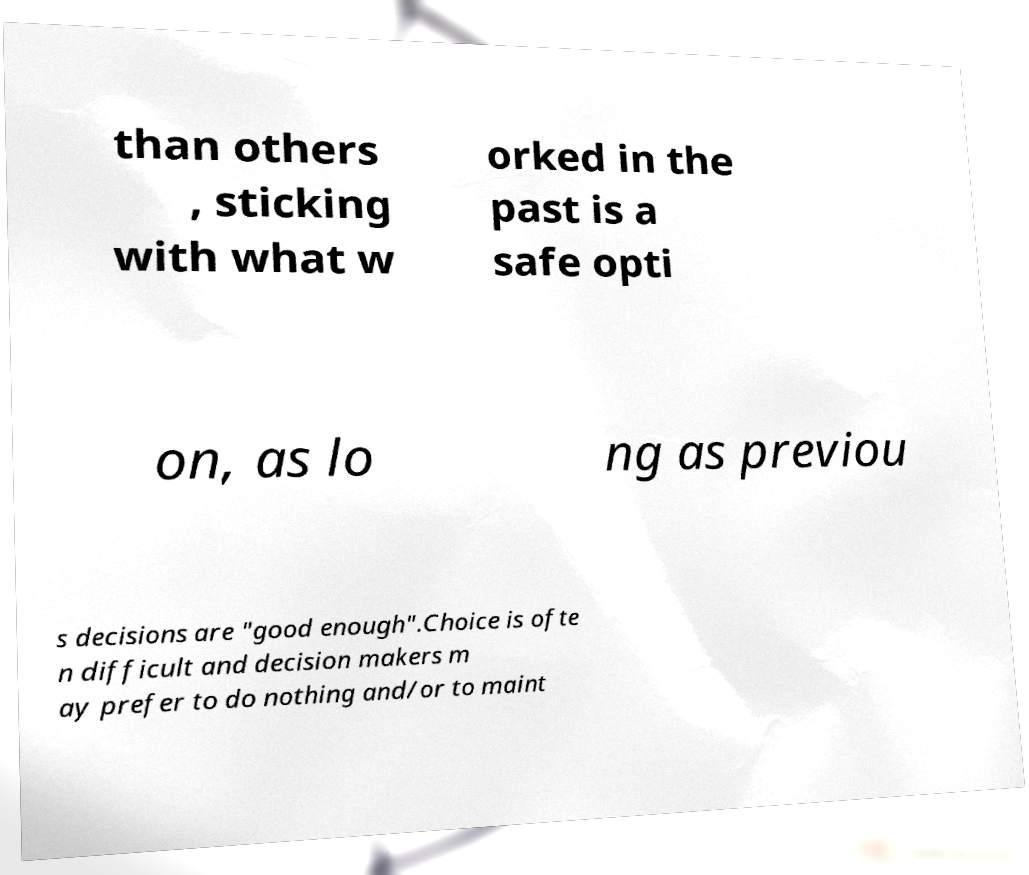Please read and relay the text visible in this image. What does it say? than others , sticking with what w orked in the past is a safe opti on, as lo ng as previou s decisions are "good enough".Choice is ofte n difficult and decision makers m ay prefer to do nothing and/or to maint 